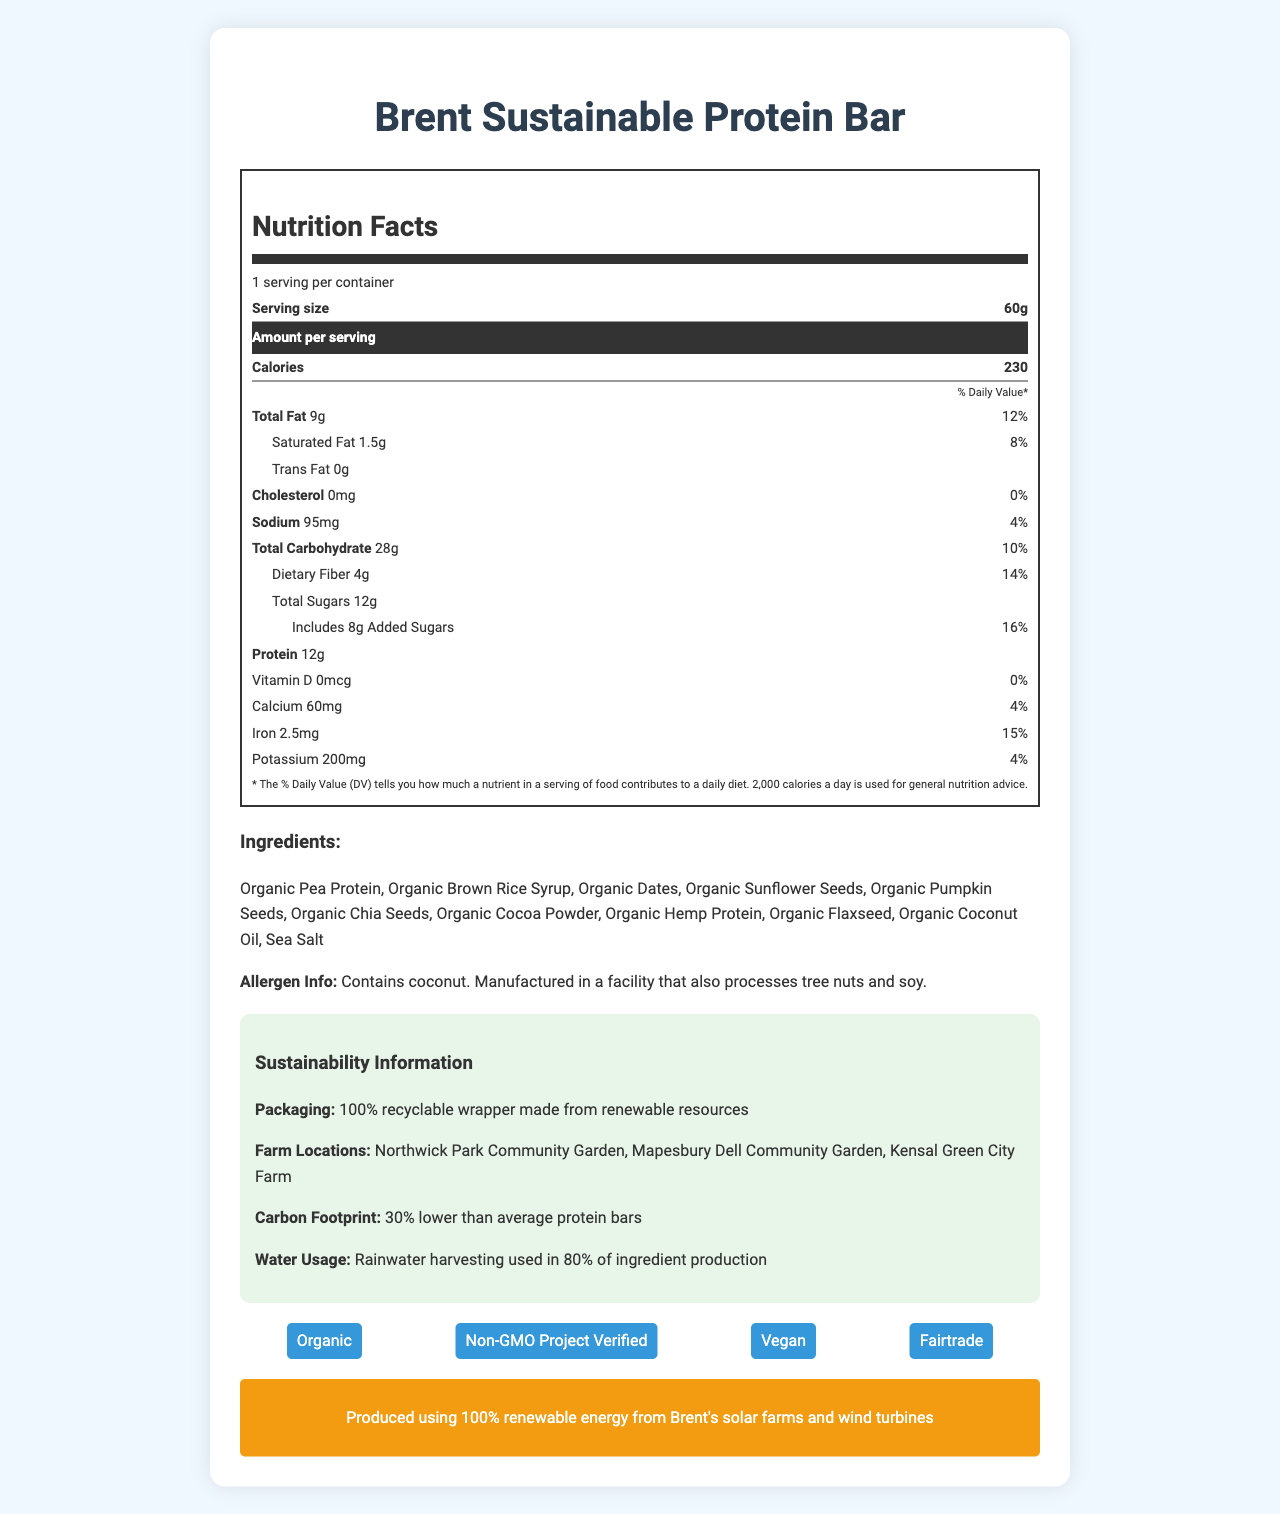what is the serving size of the Brent Sustainable Protein Bar? The document specifies the serving size as "60g."
Answer: 60g how many calories are in one serving? The document mentions that the amount of calories per serving is 230.
Answer: 230 which farm locations are mentioned in the sustainability information? The sustainability section lists these farm locations.
Answer: Northwick Park Community Garden, Mapesbury Dell Community Garden, Kensal Green City Farm what is the amount of protein per serving? The nutrition facts section states that the protein content per serving is 12g.
Answer: 12g what certifications does the Brent Sustainable Protein Bar have? The document lists these certifications under the "certifications" section.
Answer: Organic, Non-GMO Project Verified, Vegan, Fairtrade how many grams of saturated fat are in one serving of the protein bar? The document specifies that there are 1.5g of saturated fat per serving.
Answer: 1.5g how many daily values of potassium does the bar provide? The daily value for potassium listed in the document is 4%.
Answer: 4% what type of wrapper is used for packaging the protein bar? The sustainability information states that the packaging is a 100% recyclable wrapper made from renewable resources.
Answer: 100% recyclable wrapper made from renewable resources multiple-choice: what is the carbon footprint reduction of Brent Sustainable Protein Bar compared to average protein bars? A. 10% lower B. 20% lower C. 30% lower D. 40% lower The document states that the carbon footprint is 30% lower than average protein bars.
Answer: C. 30% lower multiple-choice: which ingredient listed is not a type of seed? I. Organic Pea Protein II. Organic Pumpkin Seeds III. Organic Sunflower Seeds IV. Organic Dates The document lists Organic Dates as an ingredient, which is not a type of seed.
Answer: IV. Organic Dates yes/no: is the Brent Sustainable Protein Bar manufactured in a sow-free facility? The allergen information states that the bar is manufactured in a facility that processes soy.
Answer: No summary: summarize the main idea of this document This summary condenses the main points within the document, including nutrition facts, certifications, sustainability commitments, and allergen information.
Answer: The document provides comprehensive nutrition information, ingredients, allergen warnings, and sustainability details for the Brent Sustainable Protein Bar. The bar is made with organic ingredients, is certified Vegan and Fairtrade, and uses 100% recyclable packaging. It has a low carbon footprint and utilizes water-saving agricultural practices in the local Brent area. what is the source of the renewable energy used to produce the Brent Sustainable Protein Bar? The document states that the bar is produced using renewable energy from solar farms and wind turbines in Brent.
Answer: Produced using 100% renewable energy from Brent's solar farms and wind turbines how much added sugar is in one serving? The nutrition information lists the amount of added sugars as 8g per serving.
Answer: 8g what percentage of the daily value of Vitamin D does the protein bar provide? The document states that the daily value for Vitamin D is 0%.
Answer: 0% who is the manufacturer of the Brent Sustainable Protein Bar? The document does not provide information about the manufacturer.
Answer: Cannot be determined 